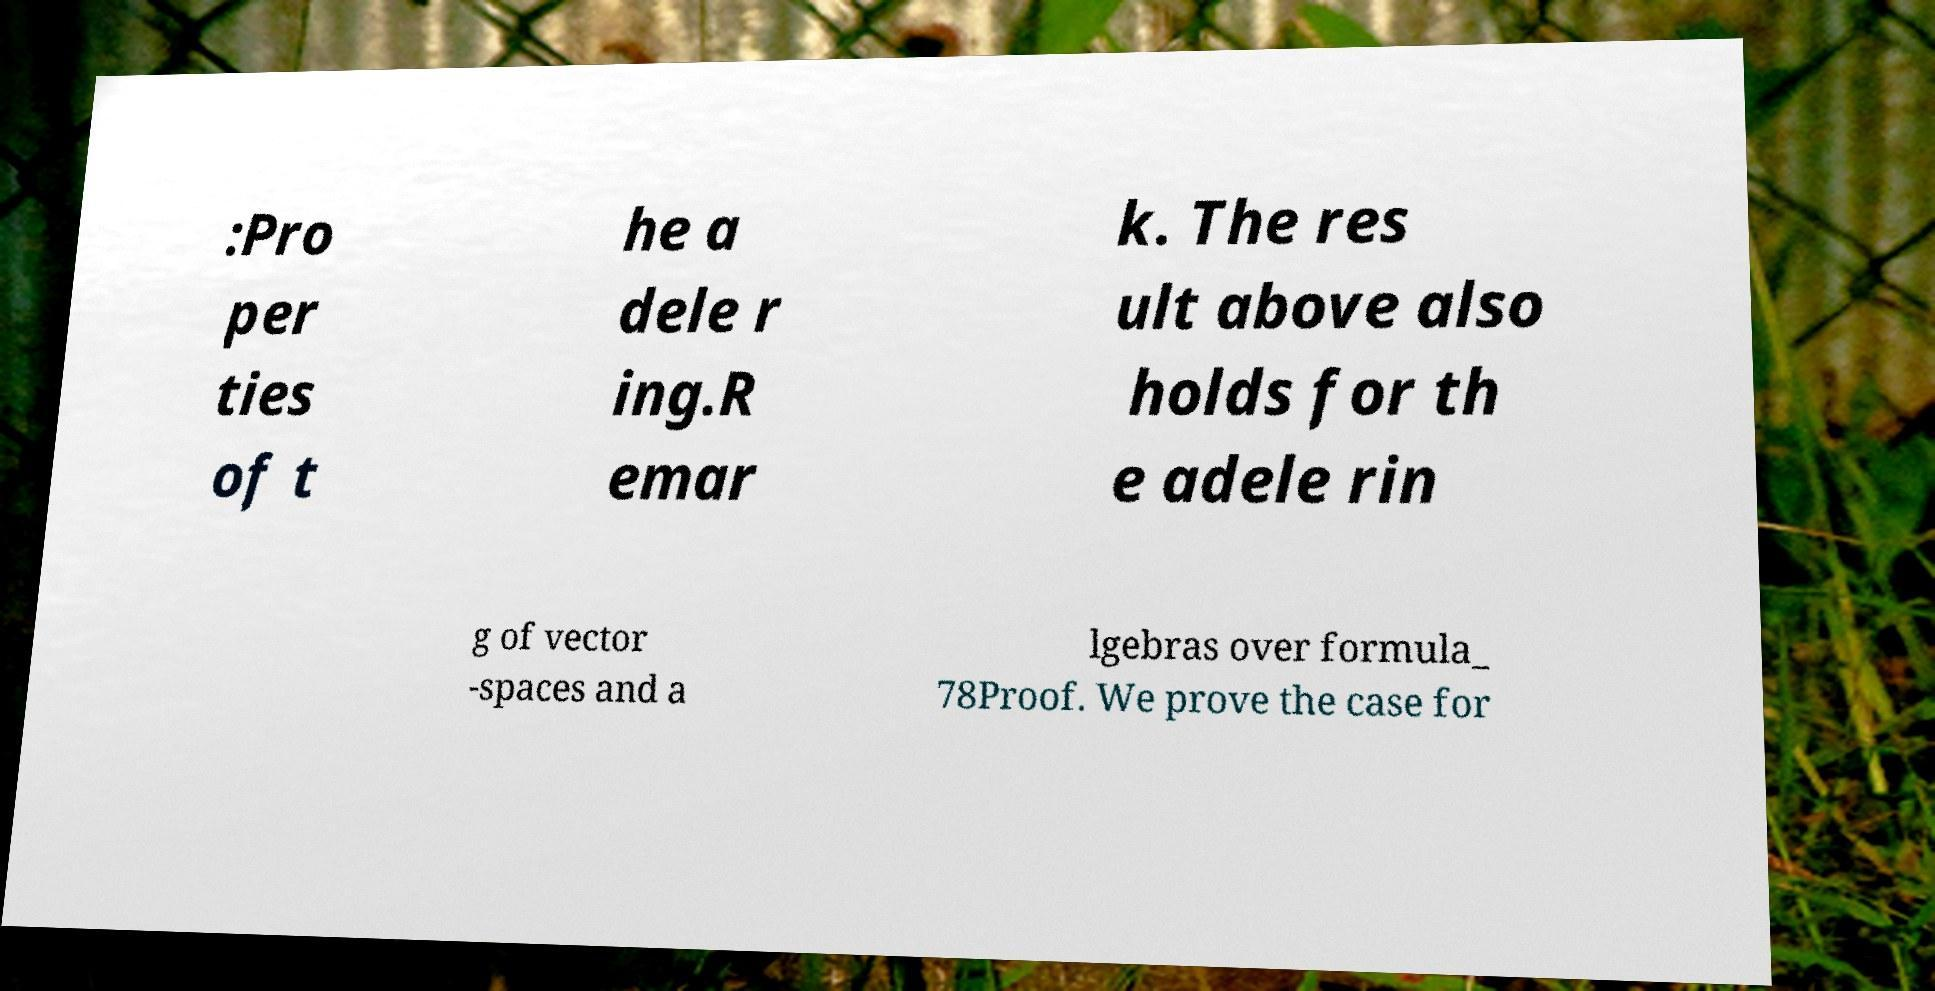There's text embedded in this image that I need extracted. Can you transcribe it verbatim? :Pro per ties of t he a dele r ing.R emar k. The res ult above also holds for th e adele rin g of vector -spaces and a lgebras over formula_ 78Proof. We prove the case for 